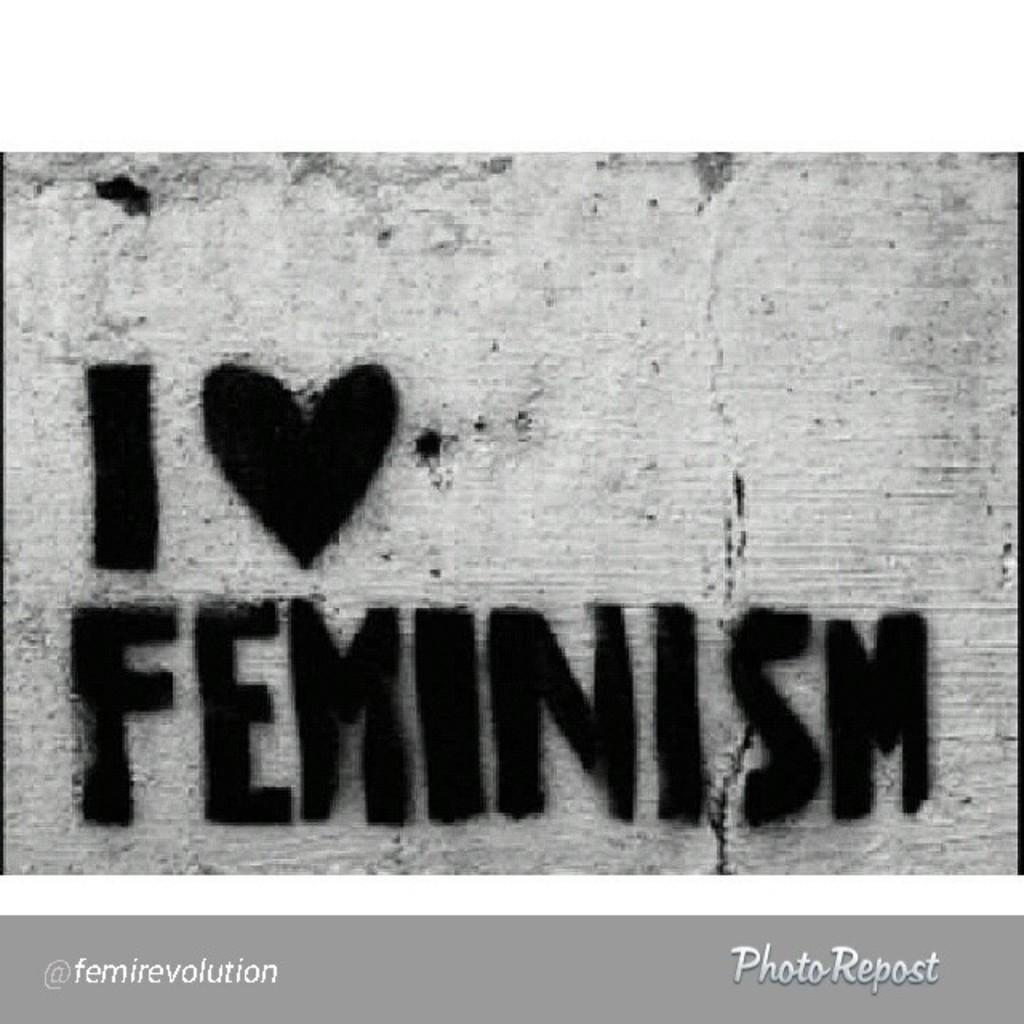<image>
Create a compact narrative representing the image presented. an I love feminism message on a surface 